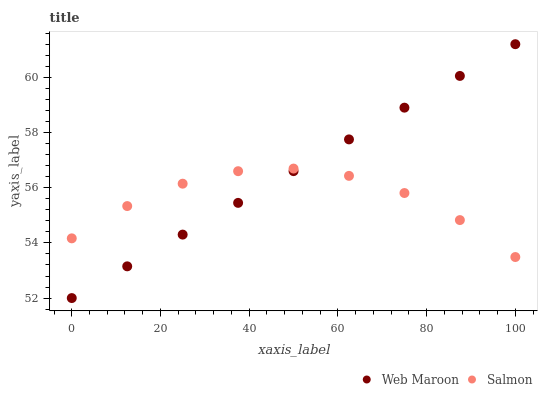Does Salmon have the minimum area under the curve?
Answer yes or no. Yes. Does Web Maroon have the maximum area under the curve?
Answer yes or no. Yes. Does Web Maroon have the minimum area under the curve?
Answer yes or no. No. Is Web Maroon the smoothest?
Answer yes or no. Yes. Is Salmon the roughest?
Answer yes or no. Yes. Is Web Maroon the roughest?
Answer yes or no. No. Does Web Maroon have the lowest value?
Answer yes or no. Yes. Does Web Maroon have the highest value?
Answer yes or no. Yes. Does Salmon intersect Web Maroon?
Answer yes or no. Yes. Is Salmon less than Web Maroon?
Answer yes or no. No. Is Salmon greater than Web Maroon?
Answer yes or no. No. 